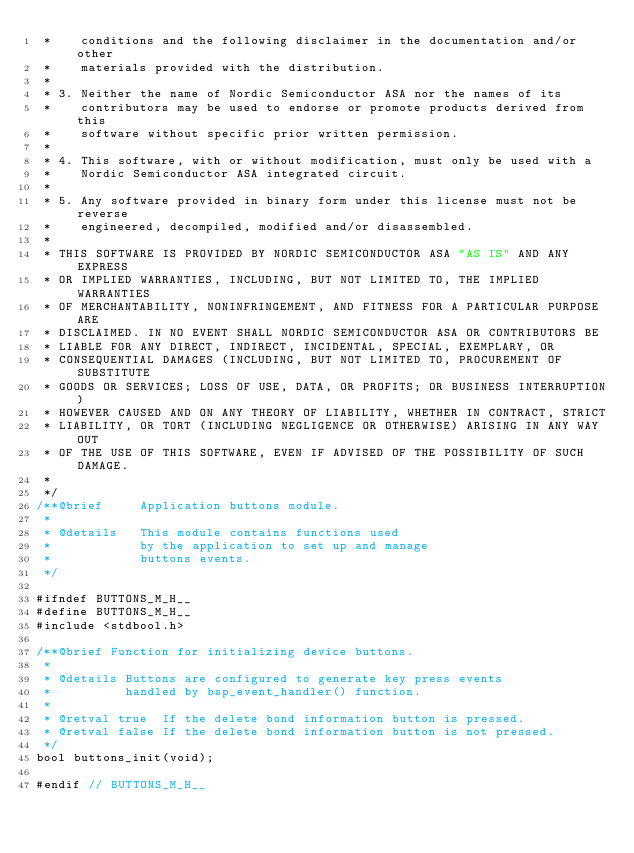Convert code to text. <code><loc_0><loc_0><loc_500><loc_500><_C_> *    conditions and the following disclaimer in the documentation and/or other
 *    materials provided with the distribution.
 *
 * 3. Neither the name of Nordic Semiconductor ASA nor the names of its
 *    contributors may be used to endorse or promote products derived from this
 *    software without specific prior written permission.
 *
 * 4. This software, with or without modification, must only be used with a
 *    Nordic Semiconductor ASA integrated circuit.
 *
 * 5. Any software provided in binary form under this license must not be reverse
 *    engineered, decompiled, modified and/or disassembled.
 *
 * THIS SOFTWARE IS PROVIDED BY NORDIC SEMICONDUCTOR ASA "AS IS" AND ANY EXPRESS
 * OR IMPLIED WARRANTIES, INCLUDING, BUT NOT LIMITED TO, THE IMPLIED WARRANTIES
 * OF MERCHANTABILITY, NONINFRINGEMENT, AND FITNESS FOR A PARTICULAR PURPOSE ARE
 * DISCLAIMED. IN NO EVENT SHALL NORDIC SEMICONDUCTOR ASA OR CONTRIBUTORS BE
 * LIABLE FOR ANY DIRECT, INDIRECT, INCIDENTAL, SPECIAL, EXEMPLARY, OR
 * CONSEQUENTIAL DAMAGES (INCLUDING, BUT NOT LIMITED TO, PROCUREMENT OF SUBSTITUTE
 * GOODS OR SERVICES; LOSS OF USE, DATA, OR PROFITS; OR BUSINESS INTERRUPTION)
 * HOWEVER CAUSED AND ON ANY THEORY OF LIABILITY, WHETHER IN CONTRACT, STRICT
 * LIABILITY, OR TORT (INCLUDING NEGLIGENCE OR OTHERWISE) ARISING IN ANY WAY OUT
 * OF THE USE OF THIS SOFTWARE, EVEN IF ADVISED OF THE POSSIBILITY OF SUCH DAMAGE.
 *
 */
/**@brief     Application buttons module.
 *
 * @details   This module contains functions used
 *            by the application to set up and manage
 *            buttons events.
 */

#ifndef BUTTONS_M_H__
#define BUTTONS_M_H__
#include <stdbool.h>

/**@brief Function for initializing device buttons.
 *
 * @details Buttons are configured to generate key press events
 *          handled by bsp_event_handler() function.
 *
 * @retval true  If the delete bond information button is pressed.
 * @retval false If the delete bond information button is not pressed.
 */
bool buttons_init(void);

#endif // BUTTONS_M_H__
</code> 